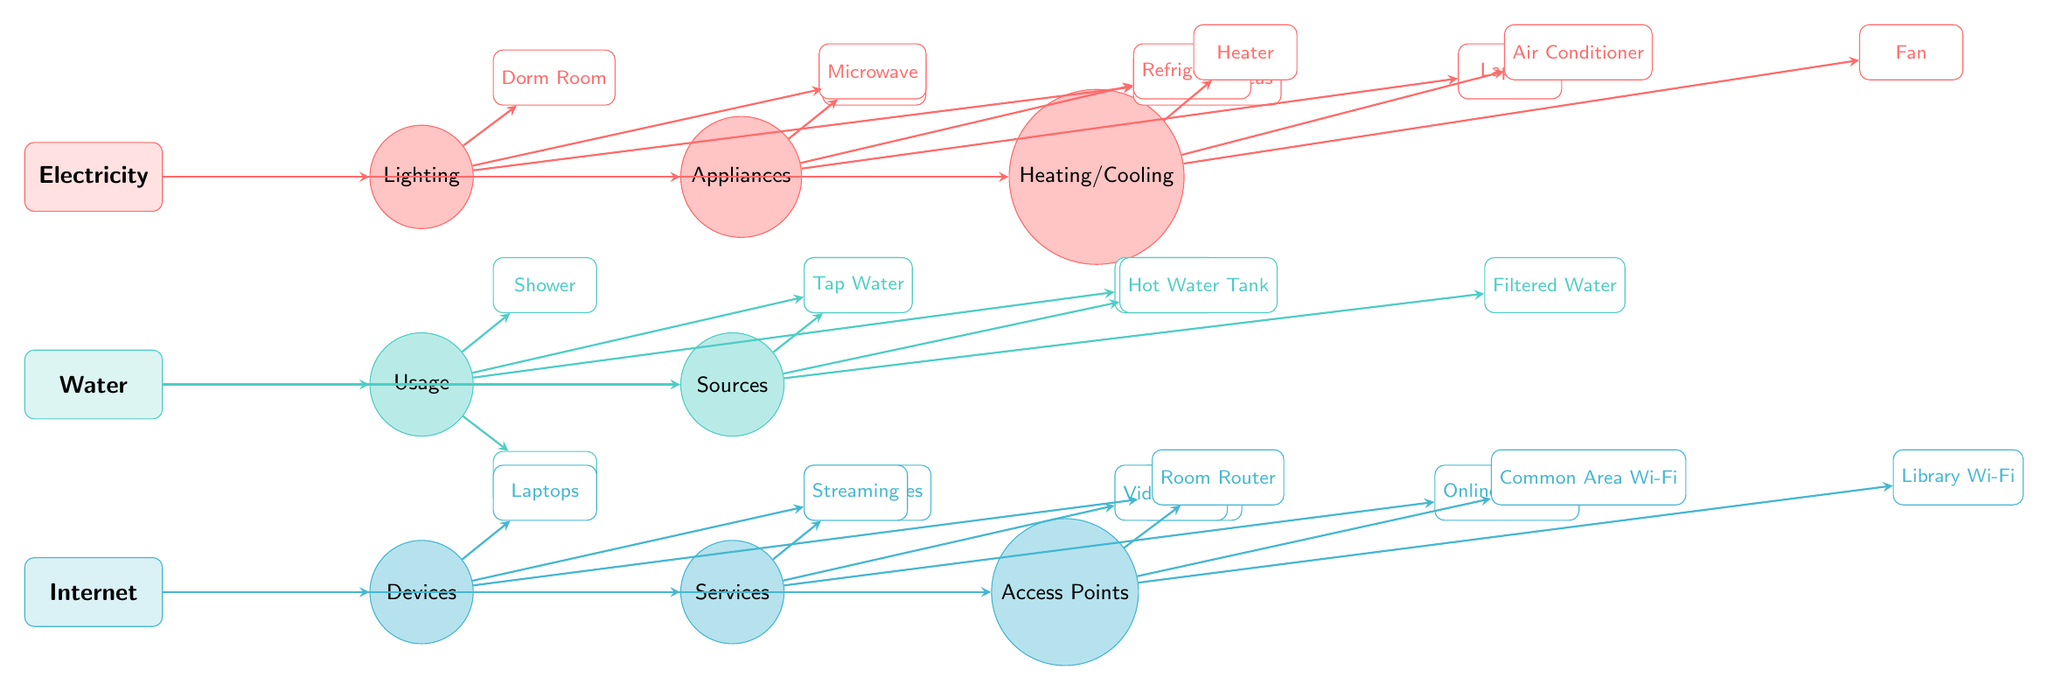What's the main resource represented at the top of the diagram? The main resource at the top is Electricity, as indicated by its placement and the corresponding color.
Answer: Electricity How many subcategories does Water have? The Water resource has two subcategories: Usage and Sources. Therefore, counting both gives a total of two.
Answer: 2 Which device is associated with the Appliances subcategory of Electricity? The third item listed under the Appliances subcategory is Laptop, as observed in the corresponding elements under the Appliances section.
Answer: Laptop What are the access points for the Internet resource? The three access points are Room Router, Common Area Wi-Fi, and Library Wi-Fi, which can be identified in the Access Points subcategory section.
Answer: Room Router, Common Area Wi-Fi, Library Wi-Fi Which usage under Water is related to cleaning? The Shower is associated with cleaning; it's listed under the Usage subcategory of Water, which relates to water consumption for hygiene purposes.
Answer: Shower How many items are included in the Lighting subcategory of Electricity? The Lighting subcategory includes three items: Dorm Room, Hallways, and Common Areas, summing up to three.
Answer: 3 Which service under the Internet resource is related to social interaction? The service that relates to social interaction is Video Calls, as listed under the Services subcategory of Internet.
Answer: Video Calls What is the relationship between the Internet Devices and Internet Services? The Internet Devices, which include Laptops, Smartphones, and Tablets, connect to the Internet Services like Streaming, Video Calls, and Online Gaming, indicating a user-device-service flow.
Answer: Connection Which source of water is specifically mentioned in the diagram? The sources of water mentioned are Tap Water, Hot Water Tank, and Filtered Water, all listed under the Sources subcategory of Water.
Answer: Tap Water, Hot Water Tank, Filtered Water 